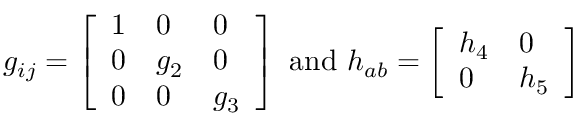<formula> <loc_0><loc_0><loc_500><loc_500>g _ { i j } = \left [ \begin{array} { l l l } { 1 } & { 0 } & { 0 } \\ { 0 } & { { g _ { 2 } } } & { 0 } \\ { 0 } & { 0 } & { { g _ { 3 } } } \end{array} \right ] a n d h _ { a b } = \left [ \begin{array} { l l } { { h _ { 4 } } } & { 0 } \\ { 0 } & { { h _ { 5 } } } \end{array} \right ]</formula> 